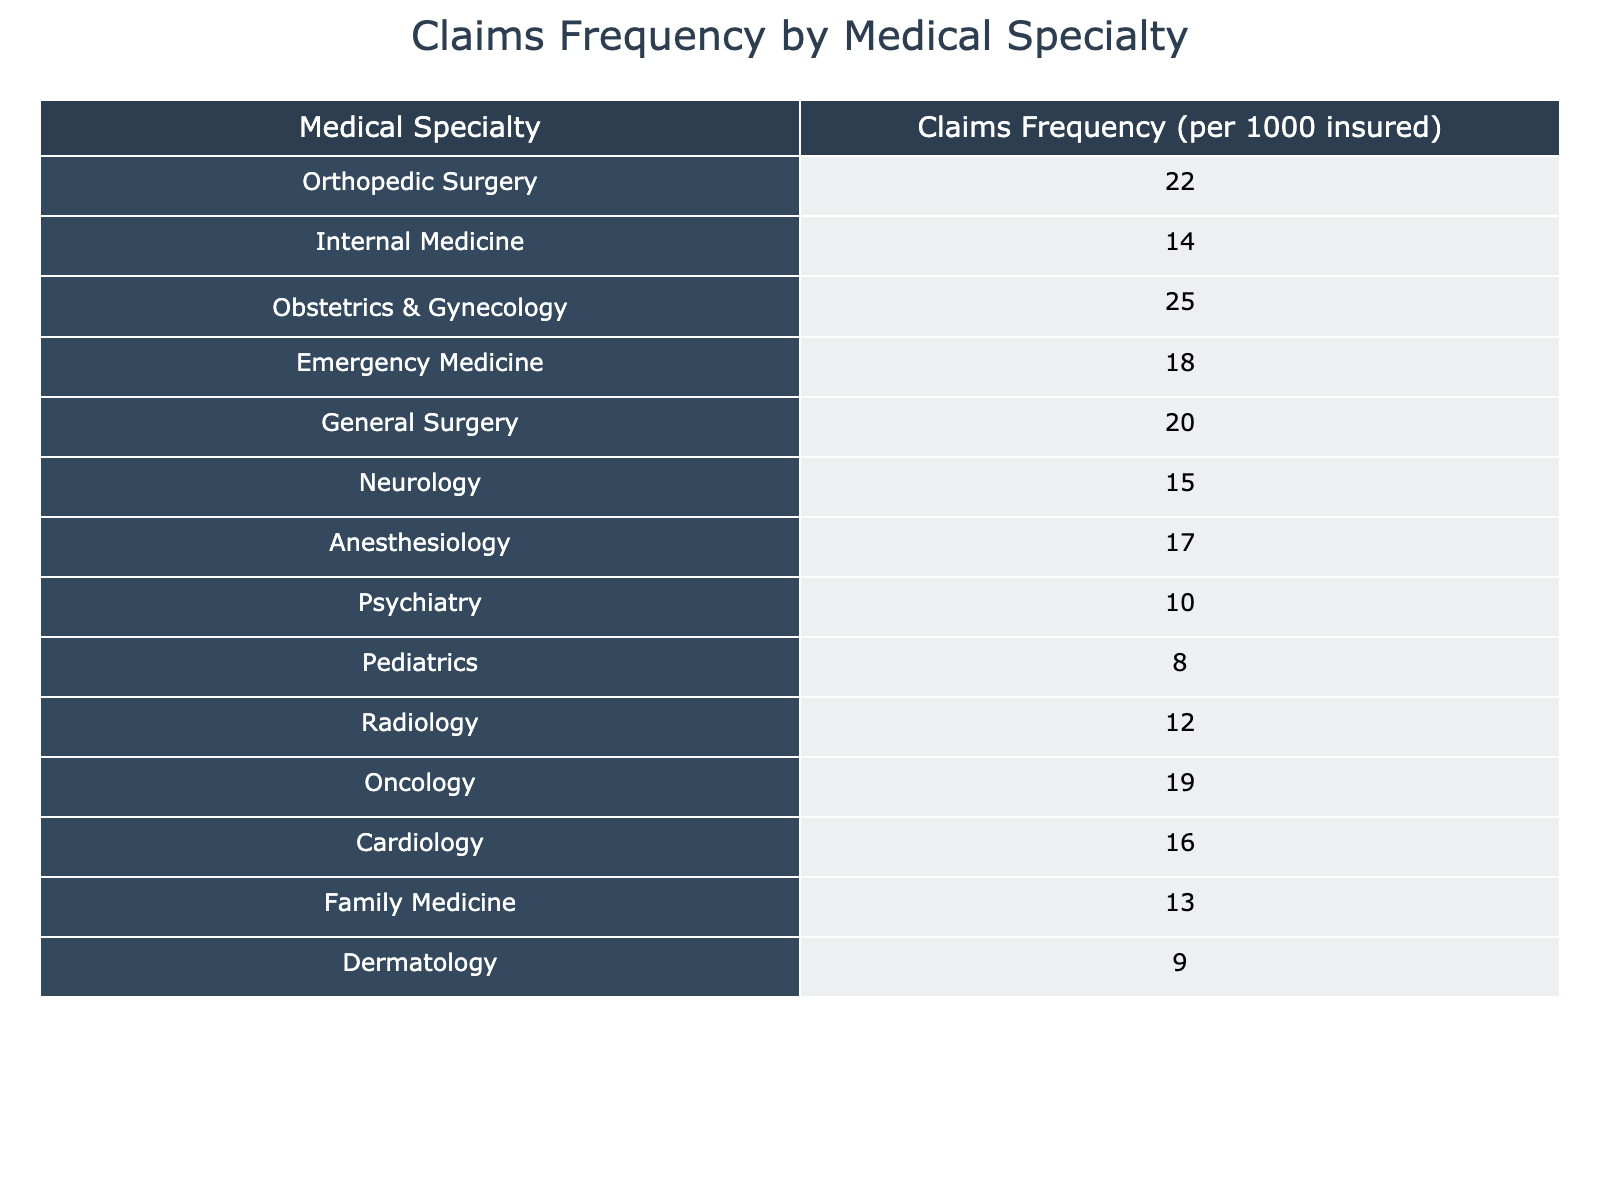What is the claims frequency for Obstetrics & Gynecology? The claims frequency for Obstetrics & Gynecology is listed directly in the table under the column "Claims Frequency (per 1000 insured)," where it shows a value of 25.
Answer: 25 Which medical specialty has the highest claims frequency? By scanning the table, Obstetrics & Gynecology has the highest claims frequency, which is 25, compared to other specialties.
Answer: Obstetrics & Gynecology What is the average claims frequency of the top three medical specialties? The top three specialties by claims frequency are Obstetrics & Gynecology (25), Orthopedic Surgery (22), and General Surgery (20). Summing those values gives us 25 + 22 + 20 = 67. There are 3 specialties, so the average is 67/3, which equals approximately 22.33.
Answer: 22.33 Is the claims frequency for Dermatology higher than that for Pediatrics? The claims frequency for Dermatology is 9, while for Pediatrics, it is 8. Since 9 is greater than 8, the statement is true.
Answer: Yes What is the total claims frequency for the specialties that have a claims frequency greater than 15? The relevant specialties are Obstetrics & Gynecology (25), Orthopedic Surgery (22), General Surgery (20), Emergency Medicine (18), Anesthesiology (17), and Cardiology (16). Adding these up gives us 25 + 22 + 20 + 18 + 17 + 16 = 118.
Answer: 118 Which specialty has a claims frequency that is 5 more than Psychiatry? Psychiatry has a claims frequency of 10. If we add 5, we get 15. Looking through the specialties, Neurology has a frequency of 15, which meets this condition.
Answer: Neurology How many medical specialties have a claims frequency less than 15? The specialties with claims frequencies less than 15 are Pediatrics (8), Dermatology (9), and Psychiatry (10). That is a total of 3 specialties.
Answer: 3 What is the difference in claims frequency between Internal Medicine and Family Medicine? Internal Medicine has a claims frequency of 14, and Family Medicine has a frequency of 13. The difference is 14 - 13 = 1.
Answer: 1 What is the total number of specialties listed with claims frequencies between 10 and 20? The specialties within that range are Internal Medicine (14), Emergency Medicine (18), General Surgery (20), Neurology (15), Anesthesiology (17), and Cardiology (16). Counting these gives us 6 specialties.
Answer: 6 